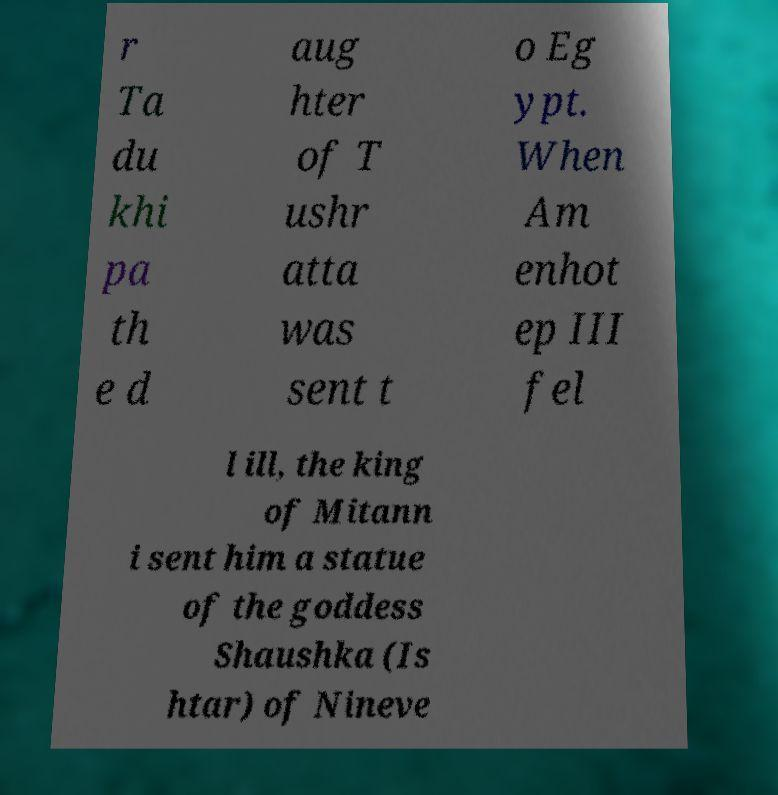There's text embedded in this image that I need extracted. Can you transcribe it verbatim? r Ta du khi pa th e d aug hter of T ushr atta was sent t o Eg ypt. When Am enhot ep III fel l ill, the king of Mitann i sent him a statue of the goddess Shaushka (Is htar) of Nineve 